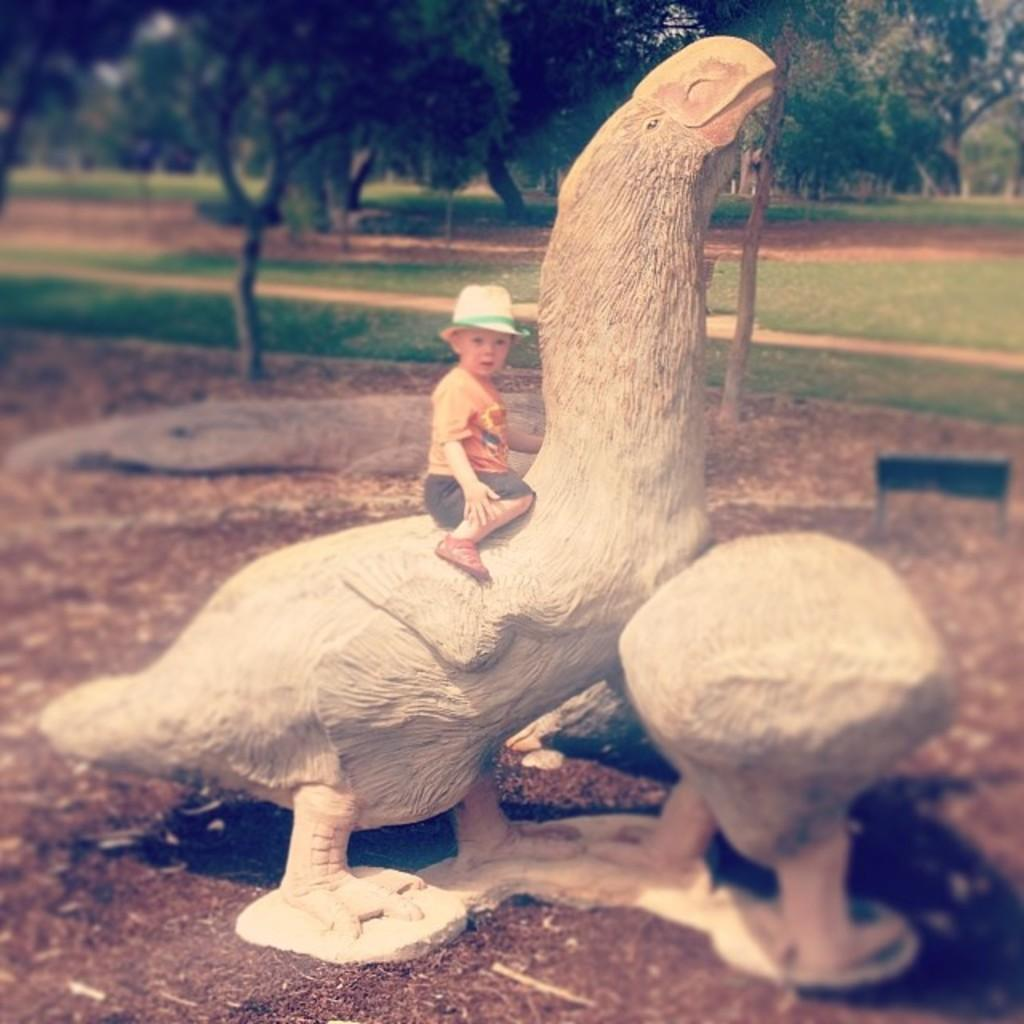What is the main subject of the image? There is a baby in the image. What is the baby sitting on? The baby is sitting on a duck statue. What can be seen in the background of the image? There are trees, a board, and green grass visible in the background. How many children are playing with the hydrant in the image? There is no hydrant present in the image, so it is not possible to answer that question. 